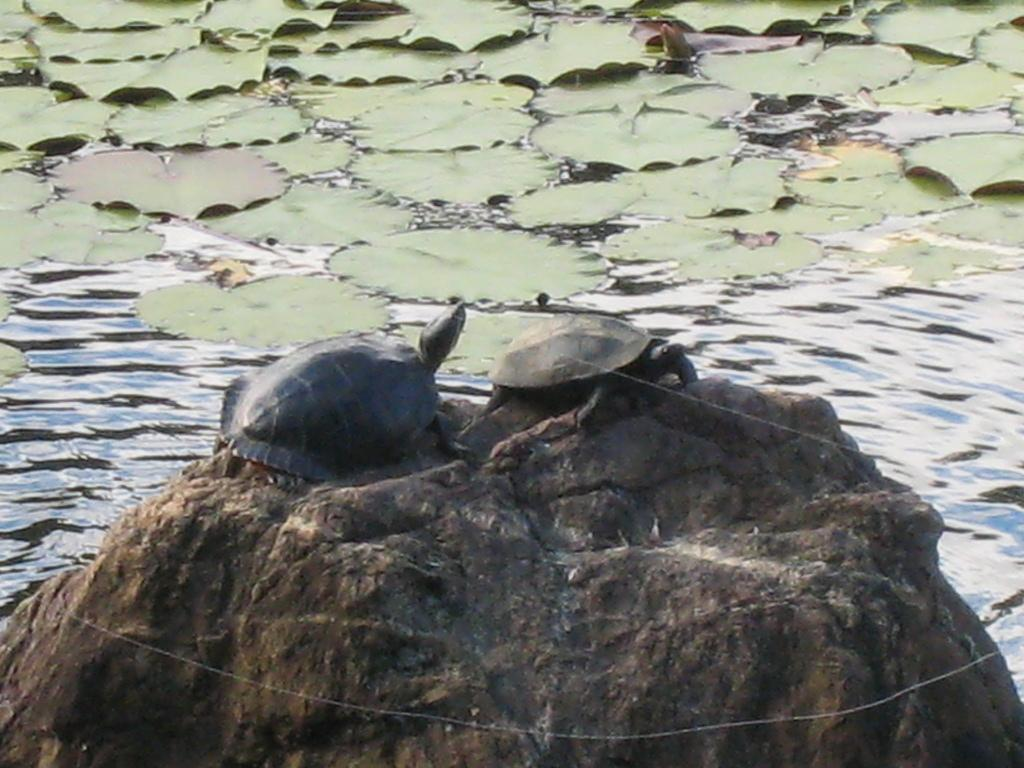What is the main subject of the image? There is a rock in the image. What is located on the rock? There are two tortoises on the rock. What can be seen in the background of the image? There are leaves and water visible in the background of the image. What type of cakes are being served at the tortoises' birthday party in the image? There is no indication of a birthday party or cakes in the image; it features a rock with two tortoises and a background with leaves and water. 